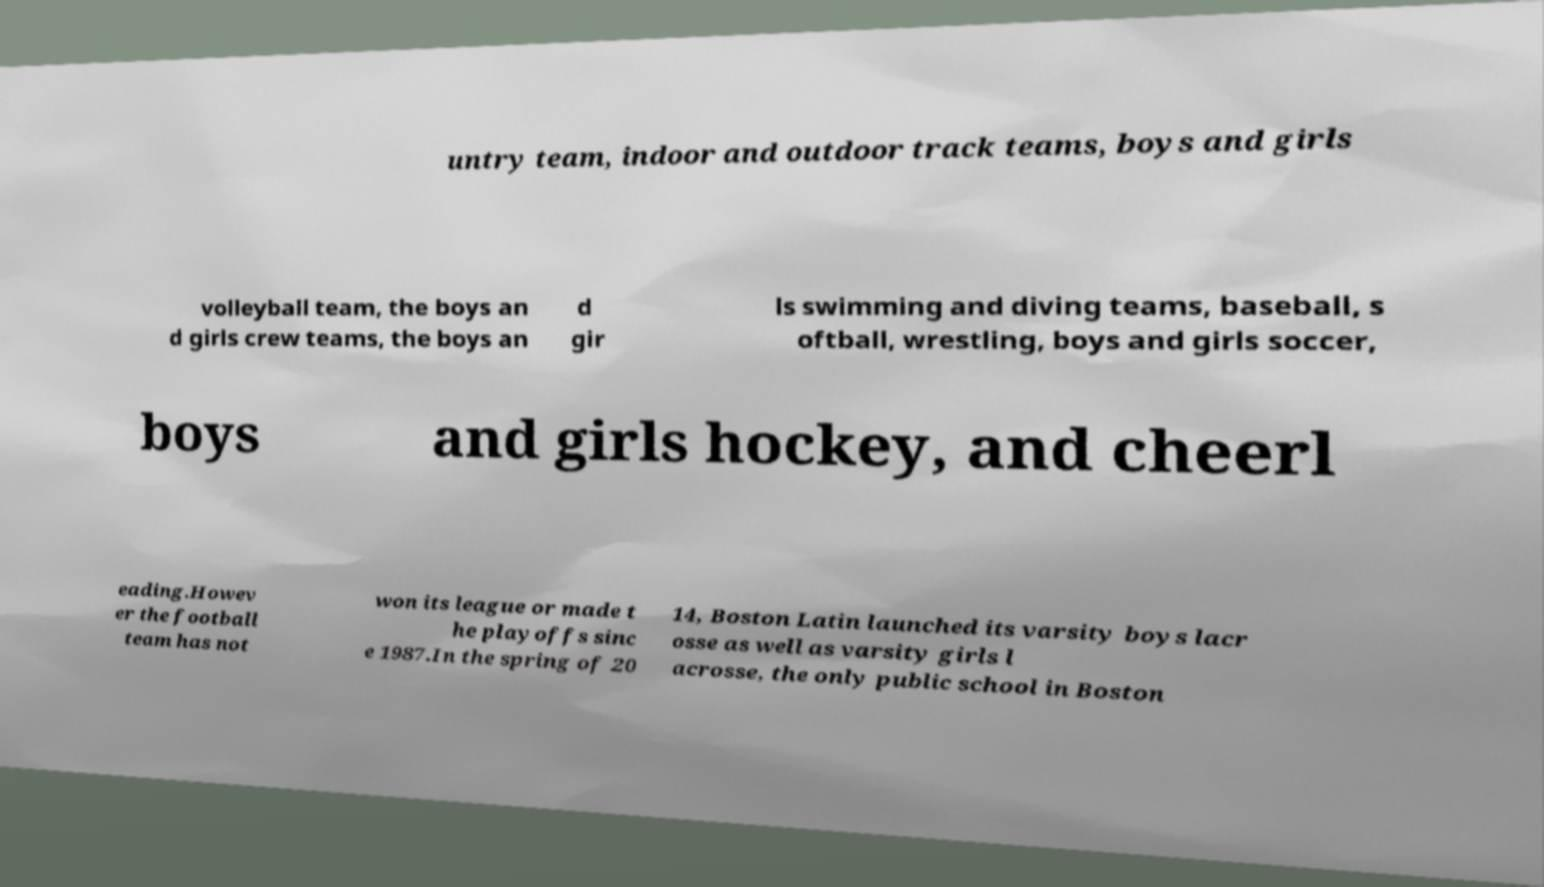Please identify and transcribe the text found in this image. untry team, indoor and outdoor track teams, boys and girls volleyball team, the boys an d girls crew teams, the boys an d gir ls swimming and diving teams, baseball, s oftball, wrestling, boys and girls soccer, boys and girls hockey, and cheerl eading.Howev er the football team has not won its league or made t he playoffs sinc e 1987.In the spring of 20 14, Boston Latin launched its varsity boys lacr osse as well as varsity girls l acrosse, the only public school in Boston 